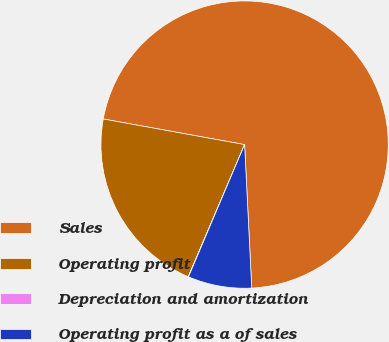Convert chart. <chart><loc_0><loc_0><loc_500><loc_500><pie_chart><fcel>Sales<fcel>Operating profit<fcel>Depreciation and amortization<fcel>Operating profit as a of sales<nl><fcel>71.35%<fcel>21.43%<fcel>0.04%<fcel>7.17%<nl></chart> 